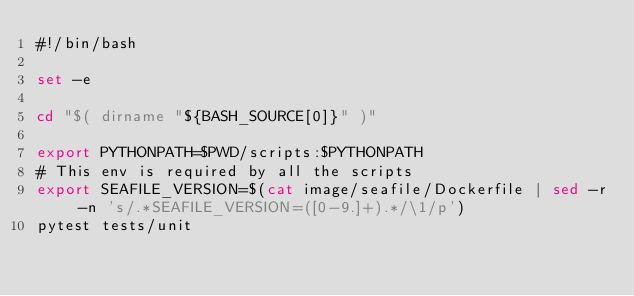Convert code to text. <code><loc_0><loc_0><loc_500><loc_500><_Bash_>#!/bin/bash

set -e

cd "$( dirname "${BASH_SOURCE[0]}" )"

export PYTHONPATH=$PWD/scripts:$PYTHONPATH
# This env is required by all the scripts
export SEAFILE_VERSION=$(cat image/seafile/Dockerfile | sed -r -n 's/.*SEAFILE_VERSION=([0-9.]+).*/\1/p')
pytest tests/unit
</code> 